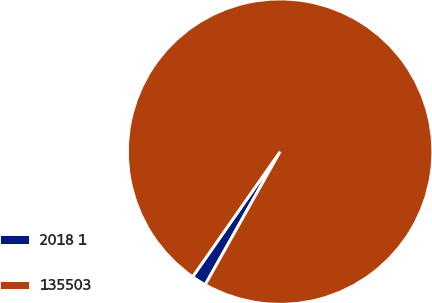Convert chart to OTSL. <chart><loc_0><loc_0><loc_500><loc_500><pie_chart><fcel>2018 1<fcel>135503<nl><fcel>1.55%<fcel>98.45%<nl></chart> 